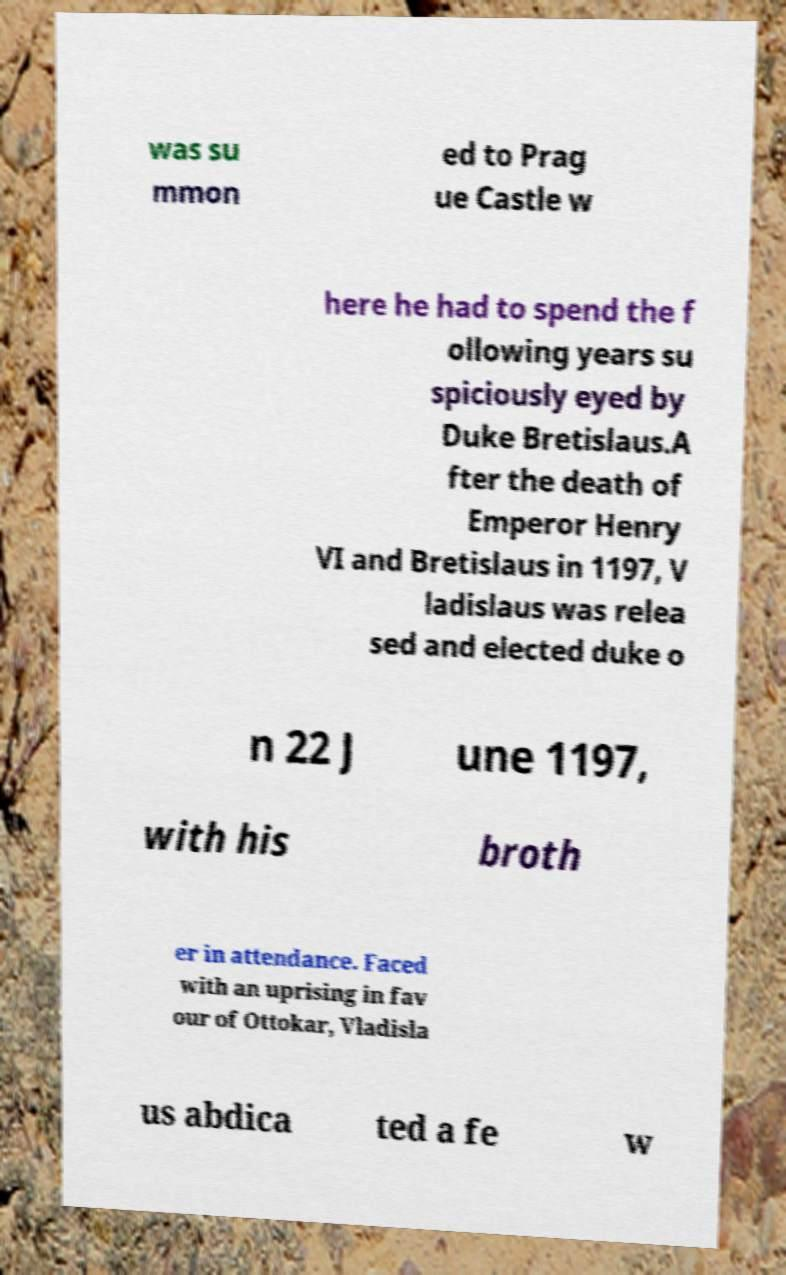Could you assist in decoding the text presented in this image and type it out clearly? was su mmon ed to Prag ue Castle w here he had to spend the f ollowing years su spiciously eyed by Duke Bretislaus.A fter the death of Emperor Henry VI and Bretislaus in 1197, V ladislaus was relea sed and elected duke o n 22 J une 1197, with his broth er in attendance. Faced with an uprising in fav our of Ottokar, Vladisla us abdica ted a fe w 